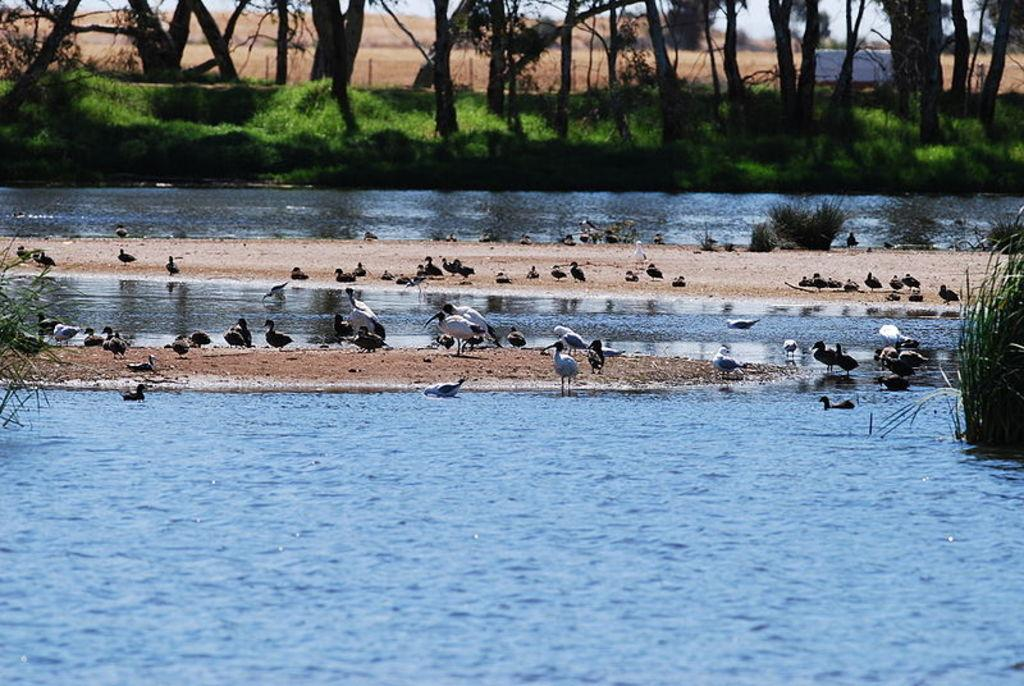What is the primary element in the image? There is water in the image. What type of animals can be seen in the image? Birds can be seen in the image. What type of vegetation is present in the image? There are plants and trees in the image. How many chairs are visible in the image? There are no chairs present in the image. 